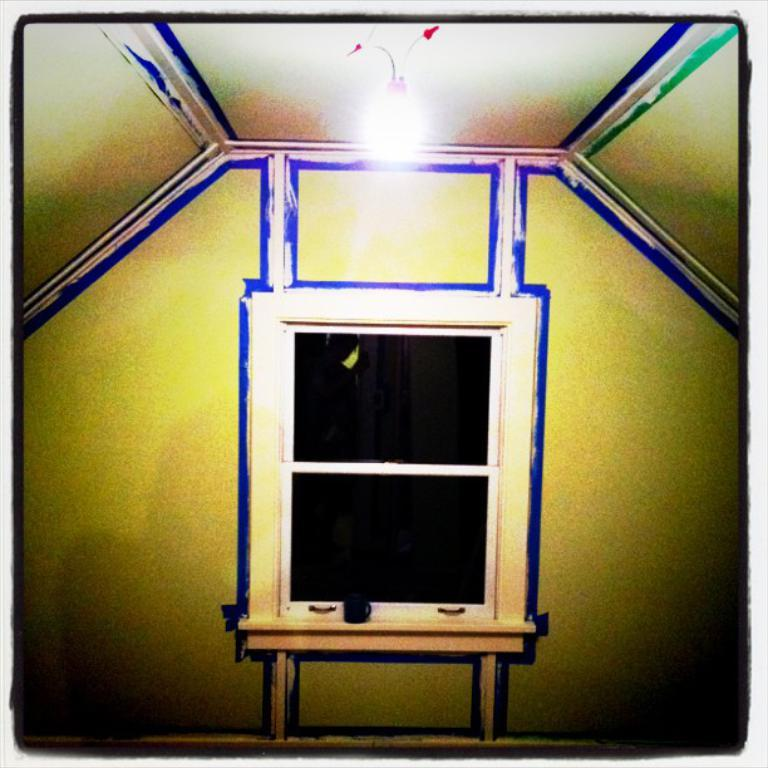What type of picture is the image? The image is an edited picture. What object can be seen on the table in the image? There is a cup on the table in the image. What architectural feature is present in the image? There is a window in the image. Where is the light source located in the image? There is a light at the top of the image. How many friends are visible in the image? There are no friends present in the image. What color is the balloon tied to the cup in the image? There is no balloon tied to the cup in the image. 